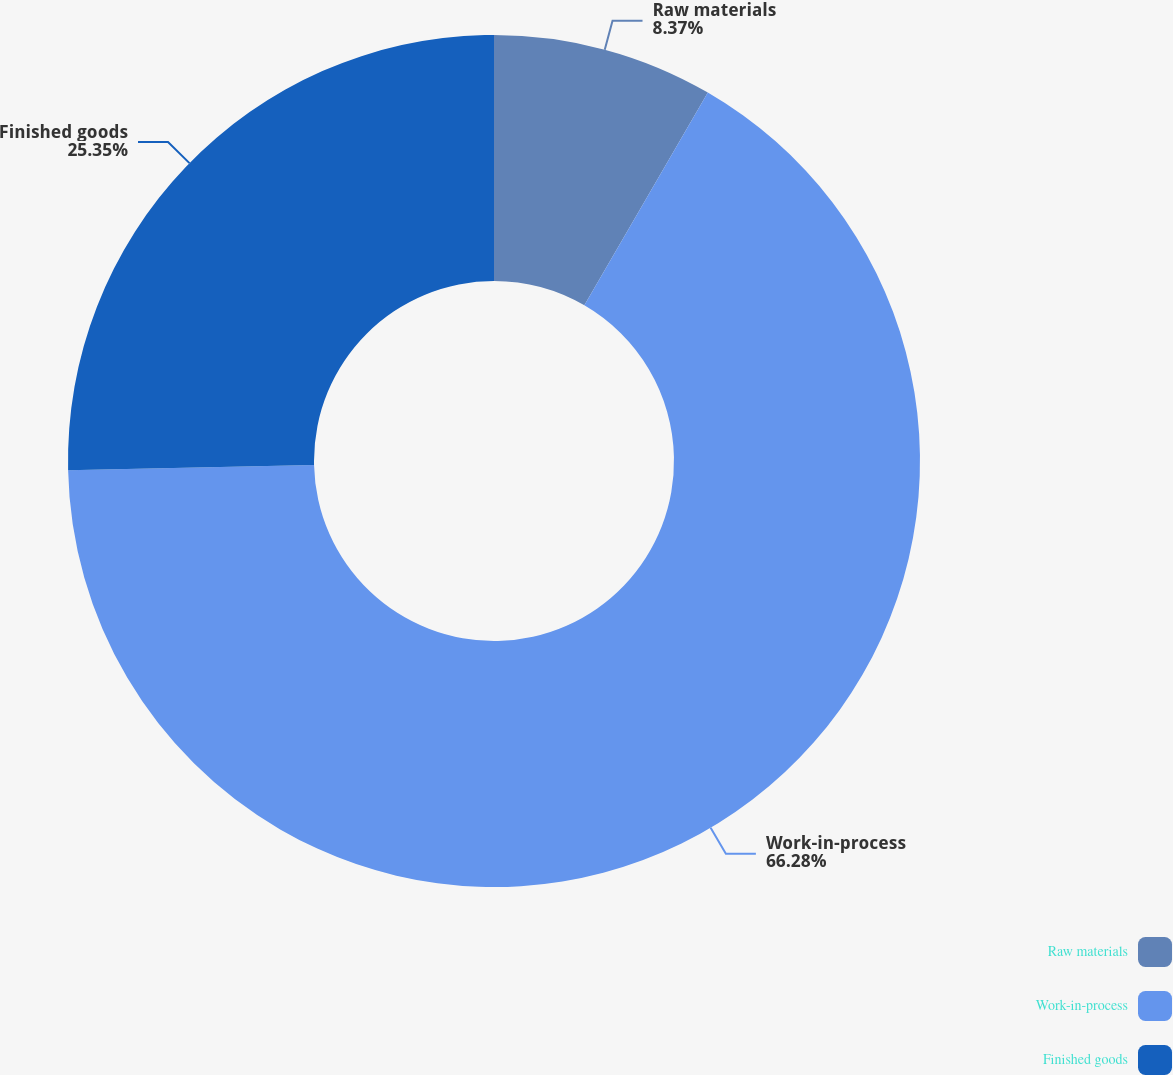Convert chart to OTSL. <chart><loc_0><loc_0><loc_500><loc_500><pie_chart><fcel>Raw materials<fcel>Work-in-process<fcel>Finished goods<nl><fcel>8.37%<fcel>66.28%<fcel>25.35%<nl></chart> 